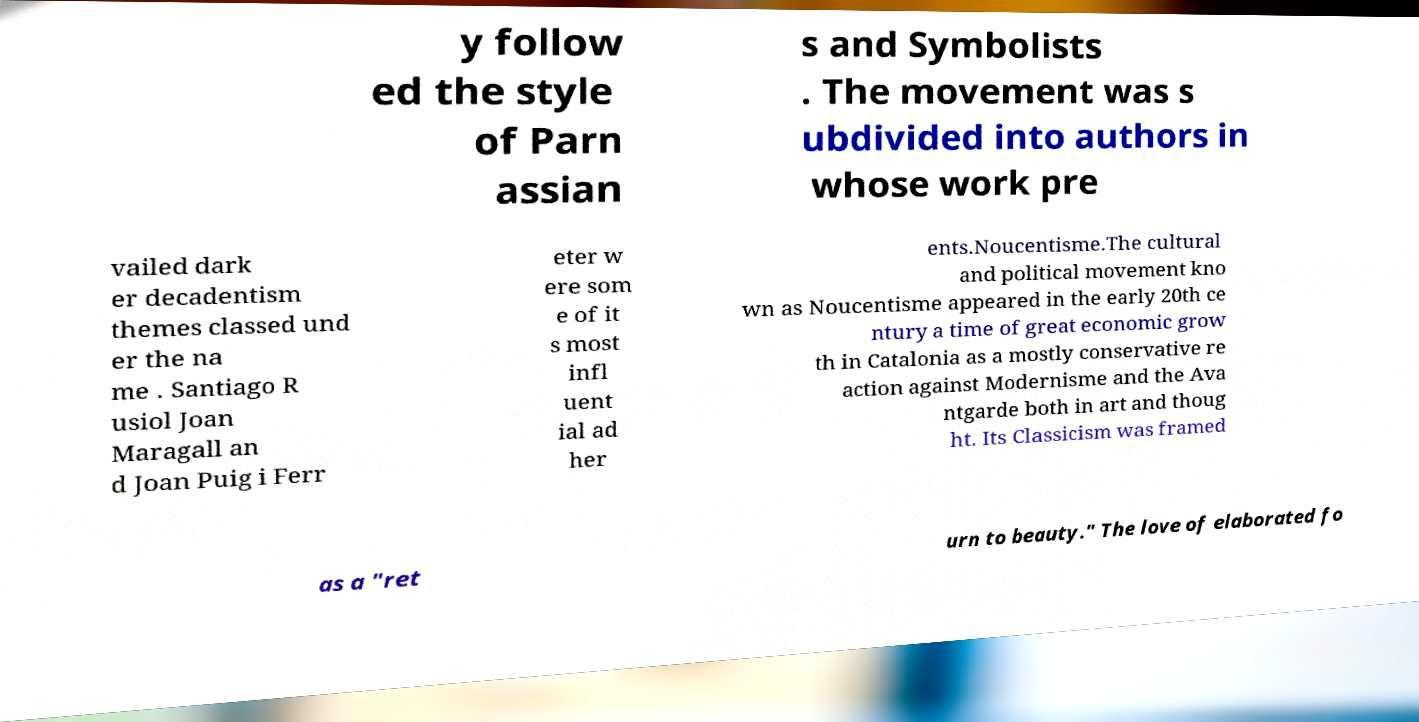Please identify and transcribe the text found in this image. y follow ed the style of Parn assian s and Symbolists . The movement was s ubdivided into authors in whose work pre vailed dark er decadentism themes classed und er the na me . Santiago R usiol Joan Maragall an d Joan Puig i Ferr eter w ere som e of it s most infl uent ial ad her ents.Noucentisme.The cultural and political movement kno wn as Noucentisme appeared in the early 20th ce ntury a time of great economic grow th in Catalonia as a mostly conservative re action against Modernisme and the Ava ntgarde both in art and thoug ht. Its Classicism was framed as a "ret urn to beauty." The love of elaborated fo 